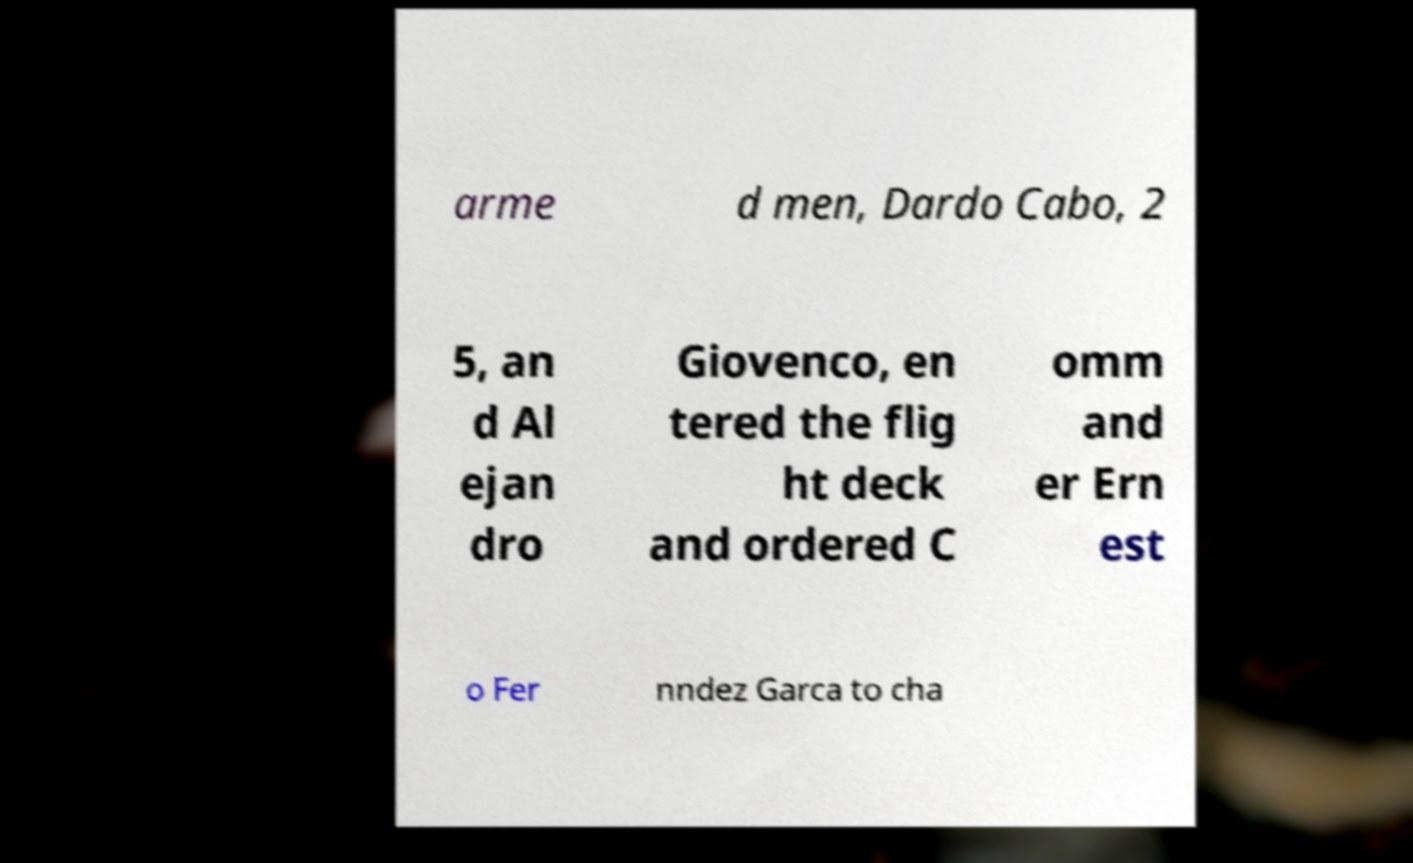Could you assist in decoding the text presented in this image and type it out clearly? arme d men, Dardo Cabo, 2 5, an d Al ejan dro Giovenco, en tered the flig ht deck and ordered C omm and er Ern est o Fer nndez Garca to cha 